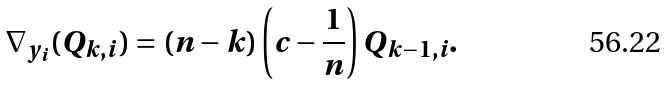<formula> <loc_0><loc_0><loc_500><loc_500>\nabla _ { y _ { i } } ( Q _ { k , i } ) = ( n - k ) \left ( c - \frac { 1 } { n } \right ) Q _ { k - 1 , i } .</formula> 